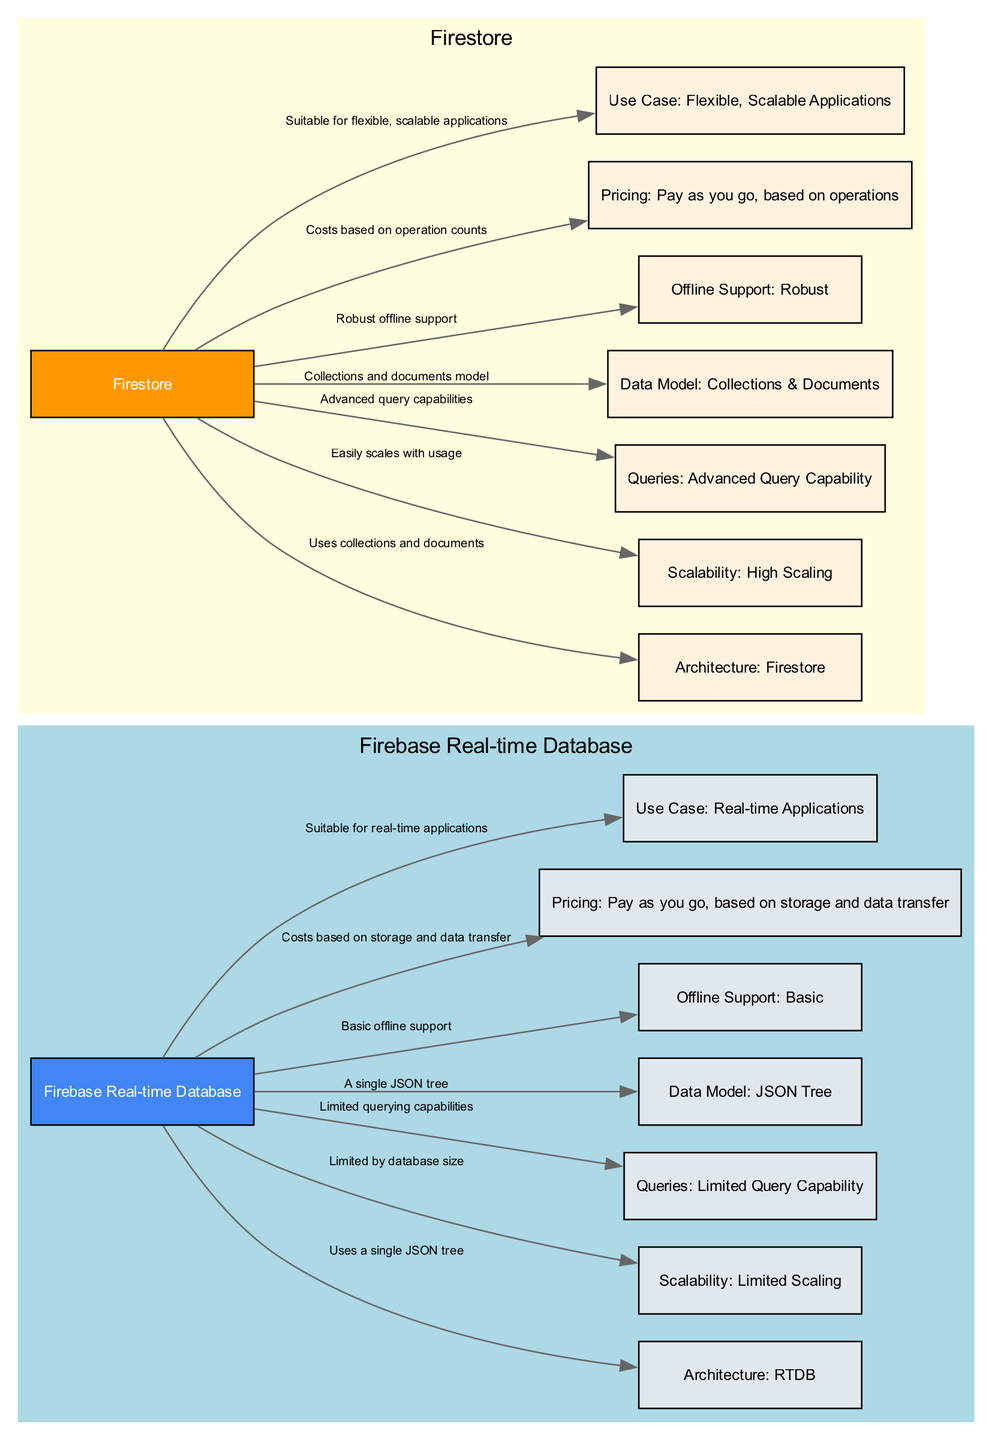What is the data model used by Firestore? The diagram shows that Firestore uses a "Collections and documents model," which can be seen in the node labeled "Data Model: Collections & Documents."
Answer: Collections and documents model What is the scalability characteristic of Firebase Real-time Database? The diagram includes a node labeled "Scalability: Limited Scaling," indicating that Firebase Real-time Database has limited scaling capabilities.
Answer: Limited Scaling How many edges connect Firebase Real-time Database to specific characteristics? By examining the edges connected to the "Firebase Real-time Database" node, I can count a total of 7 edges leading to its characteristics.
Answer: 7 What type of applications is Firestore suitable for? The diagram identifies that Firestore is "Suitable for flexible, scalable applications," as indicated in the node "Use Case: Flexible, Scalable Applications."
Answer: Flexible, scalable applications What does the Firebase Real-time Database use for its architecture? The diagram illustrates that Firebase Real-time Database "Uses a single JSON tree," as evidenced by the connection from the "Firebase Real-time Database" node to the "Architecture: RTDB" node.
Answer: A single JSON tree What is the pricing model for Firestore? The diagram indicates that Firestore's pricing is "Pay as you go, based on operations," which is specified in the corresponding node.
Answer: Pay as you go, based on operations How does Firestore's offline support compare to Firebase Real-time Database's? The diagram reveals that Firestore has "Robust offline support," while Firebase Real-time Database only has "Basic offline support," highlighting a clear difference in their capabilities.
Answer: Robust offline support What advanced feature does Firestore have over Firebase Real-time Database? The diagram points out that Firestore has "Advanced query capabilities," while Firebase Real-time Database has "Limited querying capabilities," showcasing Firestore's superior querying options.
Answer: Advanced query capabilities What is the pricing model for Firebase Real-time Database based on? The diagram specifies that Firebase Real-time Database's pricing is determined by "Costs based on storage and data transfer," as indicated in the node related to pricing.
Answer: Costs based on storage and data transfer 